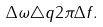<formula> <loc_0><loc_0><loc_500><loc_500>\Delta \omega \triangle q 2 \pi \Delta f .</formula> 